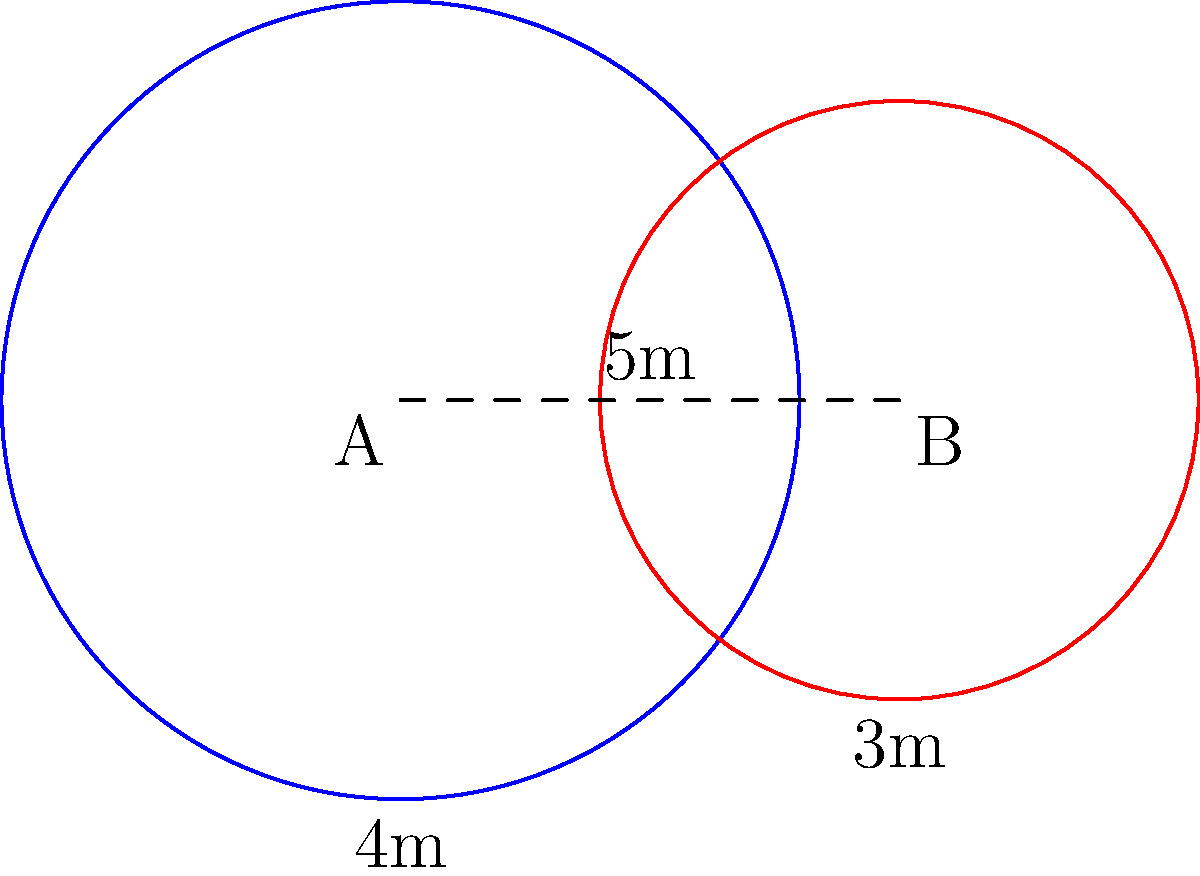As part of your sports goods business, you're designing a soccer training facility. Two circular practice zones overlap as shown in the diagram. Zone A has a radius of 4 meters, Zone B has a radius of 3 meters, and their centers are 5 meters apart. What is the area of the overlapping region between the two zones? (Use $\pi = 3.14$ for calculations) To find the area of overlap between two circles, we can use the formula:

$$A = r_1^2 \arccos(\frac{d^2 + r_1^2 - r_2^2}{2dr_1}) + r_2^2 \arccos(\frac{d^2 + r_2^2 - r_1^2}{2dr_2}) - \frac{1}{2}\sqrt{(-d+r_1+r_2)(d+r_1-r_2)(d-r_1+r_2)(d+r_1+r_2)}$$

Where:
$r_1$ = radius of circle A = 4 m
$r_2$ = radius of circle B = 3 m
$d$ = distance between centers = 5 m

Step 1: Calculate the first term
$$r_1^2 \arccos(\frac{d^2 + r_1^2 - r_2^2}{2dr_1}) = 16 \arccos(\frac{25 + 16 - 9}{2 \cdot 5 \cdot 4}) = 16 \arccos(0.8) = 16 \cdot 0.6435 = 10.296$$

Step 2: Calculate the second term
$$r_2^2 \arccos(\frac{d^2 + r_2^2 - r_1^2}{2dr_2}) = 9 \arccos(\frac{25 + 9 - 16}{2 \cdot 5 \cdot 3}) = 9 \arccos(0.6) = 9 \cdot 0.9273 = 8.3457$$

Step 3: Calculate the third term
$$\frac{1}{2}\sqrt{(-d+r_1+r_2)(d+r_1-r_2)(d-r_1+r_2)(d+r_1+r_2)} = \frac{1}{2}\sqrt{(2)(2)(1)(12)} = \frac{1}{2}\sqrt{48} = 3.4641$$

Step 4: Sum up the terms
$$A = 10.296 + 8.3457 - 3.4641 = 15.1776 \text{ m}^2$$

Step 5: Round to two decimal places
$$A \approx 15.18 \text{ m}^2$$
Answer: 15.18 m² 